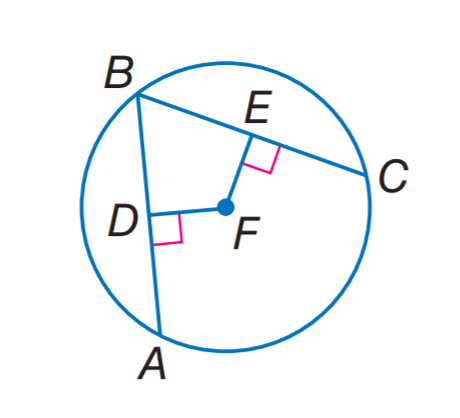Question: In \odot F, A B \cong B C, D F = 3 x - 7, and F E = x + 9. What is x?
Choices:
A. 4
B. 7
C. 8
D. 9
Answer with the letter. Answer: C 